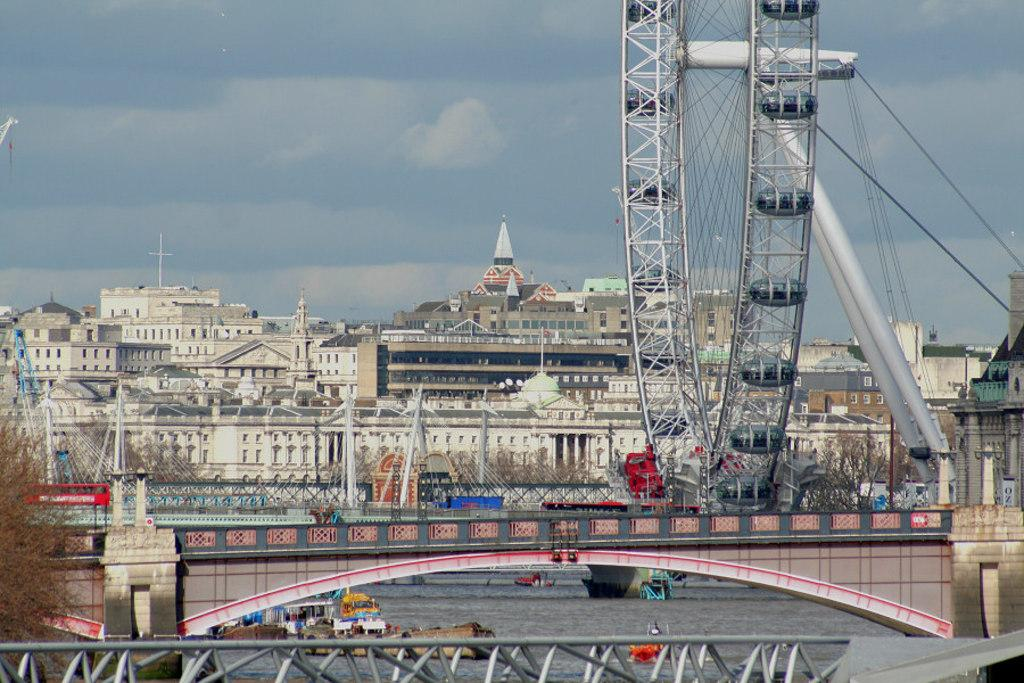What structure is present in the image that allows people and vehicles to cross over water? There is a bridge in the image. What mode of transportation can be seen in the water? There is a boat in the water. What type of structures can be seen in the background of the image? There are buildings and a giant wheel in the background. What type of vegetation is present in the image? There is a tree in the image. What is the condition of the sky in the image? The sky is clear in the image. What type of sack is being used to make a selection in the image? There is no sack or selection process present in the image. How do the people in the image say good-bye to each other? There are no people present in the image, so it is not possible to determine how they would say good-bye. 